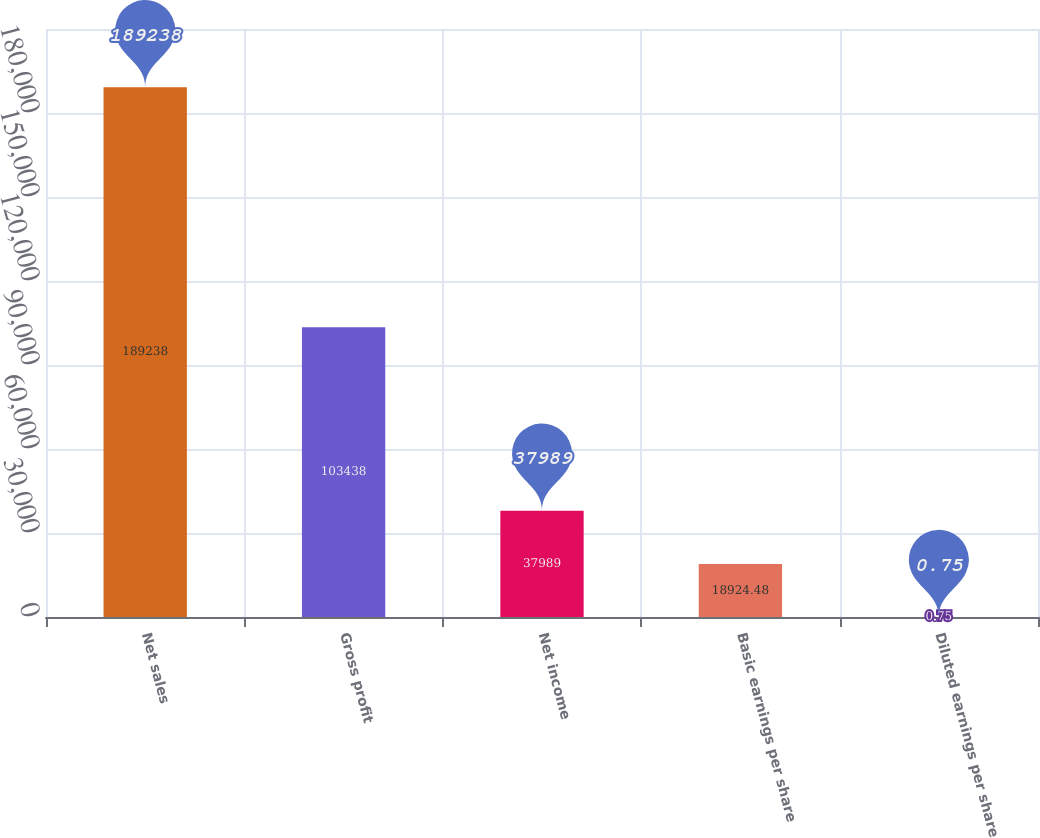Convert chart to OTSL. <chart><loc_0><loc_0><loc_500><loc_500><bar_chart><fcel>Net sales<fcel>Gross profit<fcel>Net income<fcel>Basic earnings per share<fcel>Diluted earnings per share<nl><fcel>189238<fcel>103438<fcel>37989<fcel>18924.5<fcel>0.75<nl></chart> 